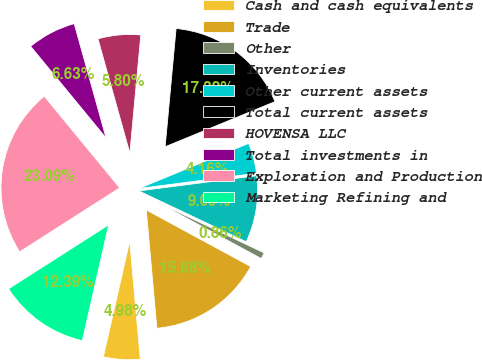Convert chart to OTSL. <chart><loc_0><loc_0><loc_500><loc_500><pie_chart><fcel>Cash and cash equivalents<fcel>Trade<fcel>Other<fcel>Inventories<fcel>Other current assets<fcel>Total current assets<fcel>HOVENSA LLC<fcel>Total investments in<fcel>Exploration and Production<fcel>Marketing Refining and<nl><fcel>4.98%<fcel>15.68%<fcel>0.86%<fcel>9.09%<fcel>4.16%<fcel>17.32%<fcel>5.8%<fcel>6.63%<fcel>23.09%<fcel>12.39%<nl></chart> 